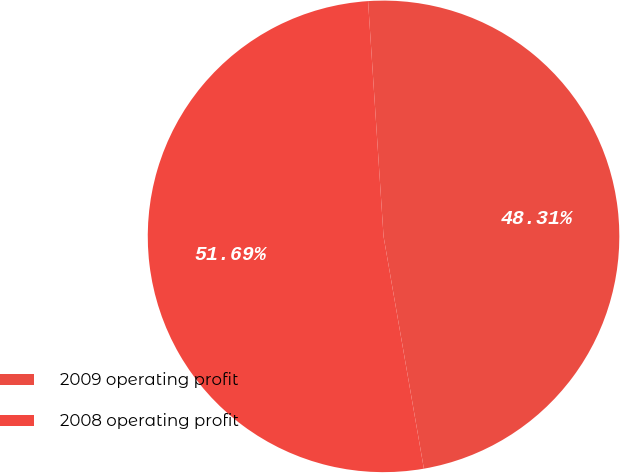Convert chart. <chart><loc_0><loc_0><loc_500><loc_500><pie_chart><fcel>2009 operating profit<fcel>2008 operating profit<nl><fcel>48.31%<fcel>51.69%<nl></chart> 